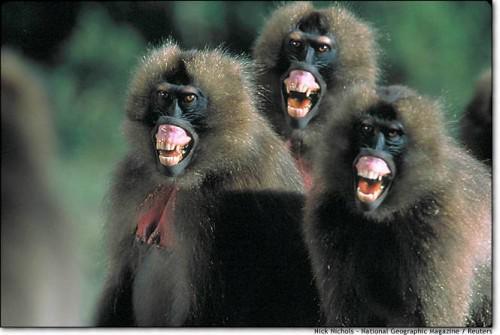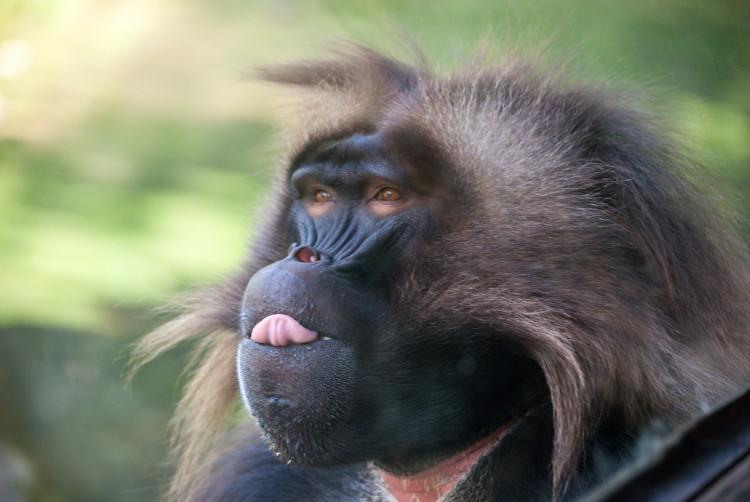The first image is the image on the left, the second image is the image on the right. For the images shown, is this caption "A total of four monkeys are shown." true? Answer yes or no. Yes. 